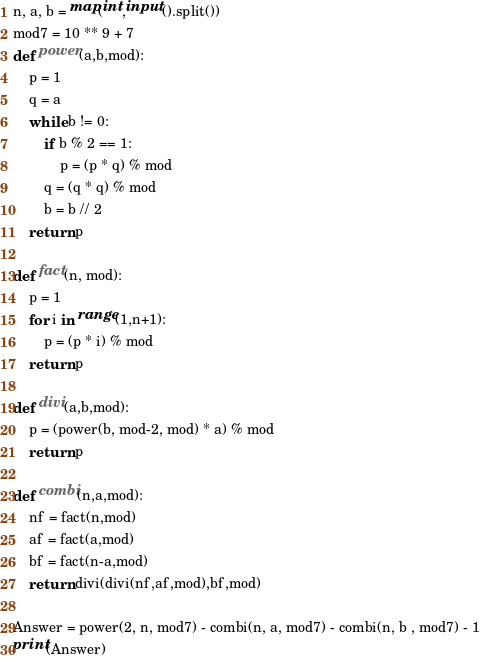<code> <loc_0><loc_0><loc_500><loc_500><_Python_>n, a, b = map(int,input().split())
mod7 = 10 ** 9 + 7
def power(a,b,mod):
    p = 1
    q = a
    while b != 0:
        if b % 2 == 1:
            p = (p * q) % mod
        q = (q * q) % mod
        b = b // 2
    return p

def fact(n, mod):
    p = 1
    for i in range(1,n+1):
        p = (p * i) % mod
    return p

def divi(a,b,mod):
    p = (power(b, mod-2, mod) * a) % mod
    return p

def combi(n,a,mod):
    nf = fact(n,mod)
    af = fact(a,mod)
    bf = fact(n-a,mod)
    return divi(divi(nf,af,mod),bf,mod)

Answer = power(2, n, mod7) - combi(n, a, mod7) - combi(n, b , mod7) - 1
print(Answer)</code> 